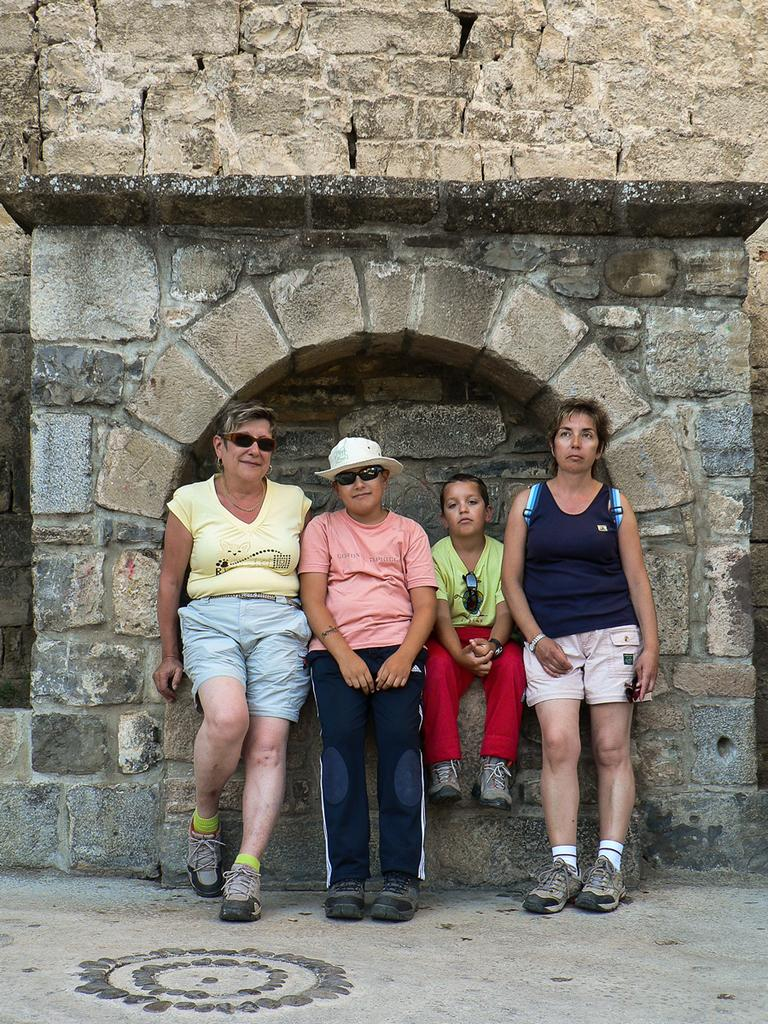What type of surface can be seen in the image? There is ground visible in the image. How many people are present in the image? There are four people in the image. Can you describe the gender of the people in the image? Two of the people are women. What are the women wearing that is related to their eyes? The women are wearing goggles. What expression do the women have in the image? The women are smiling. What can be seen in the background of the image? There is a wall in the background of the image. What type of plant is the women reacting to in the image? There is no plant present in the image, and the women are not reacting to anything. What type of celebration is happening in the image? There is no indication of a celebration in the image, such as a birthday. 